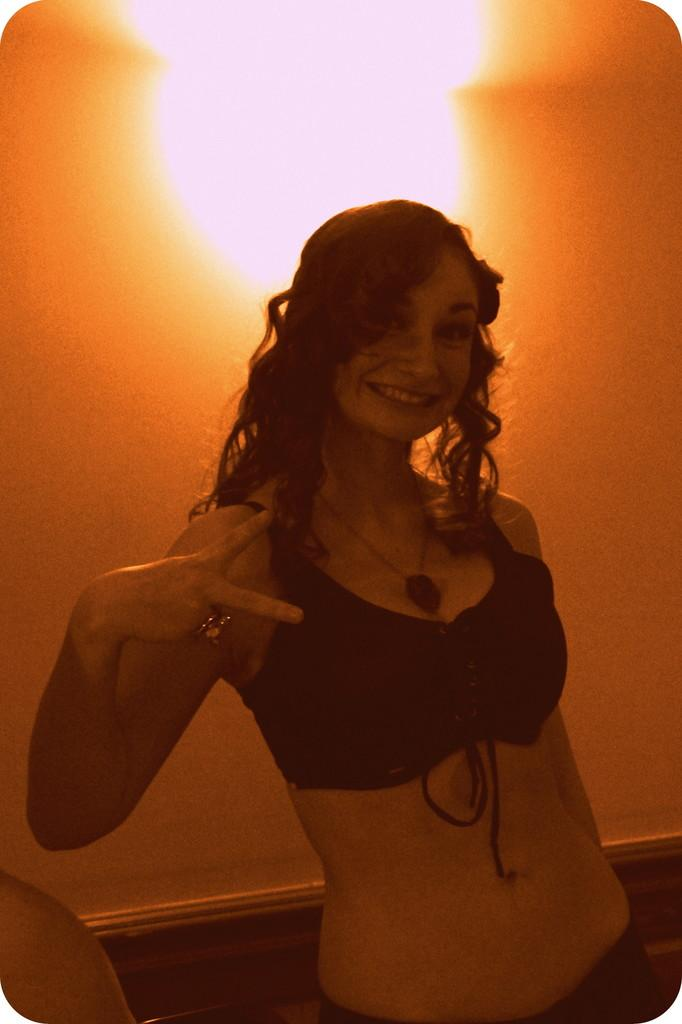Who is the main subject in the image? There is a woman in the image. What is the woman wearing? The woman is wearing a black bikini. What expression does the woman have? The woman is smiling. What is the woman doing in the image? The woman is standing and showing a symbol. What can be seen in the background of the image? There is a light in the background of the image. Where is the light located in relation to the wall? The light is near a wall. What type of soap is the woman using in the image? There is no soap present in the image. What does the woman need to complete her task in the image? The image does not depict a task that requires any specific item or tool, so it is not possible to determine what the woman might need. 